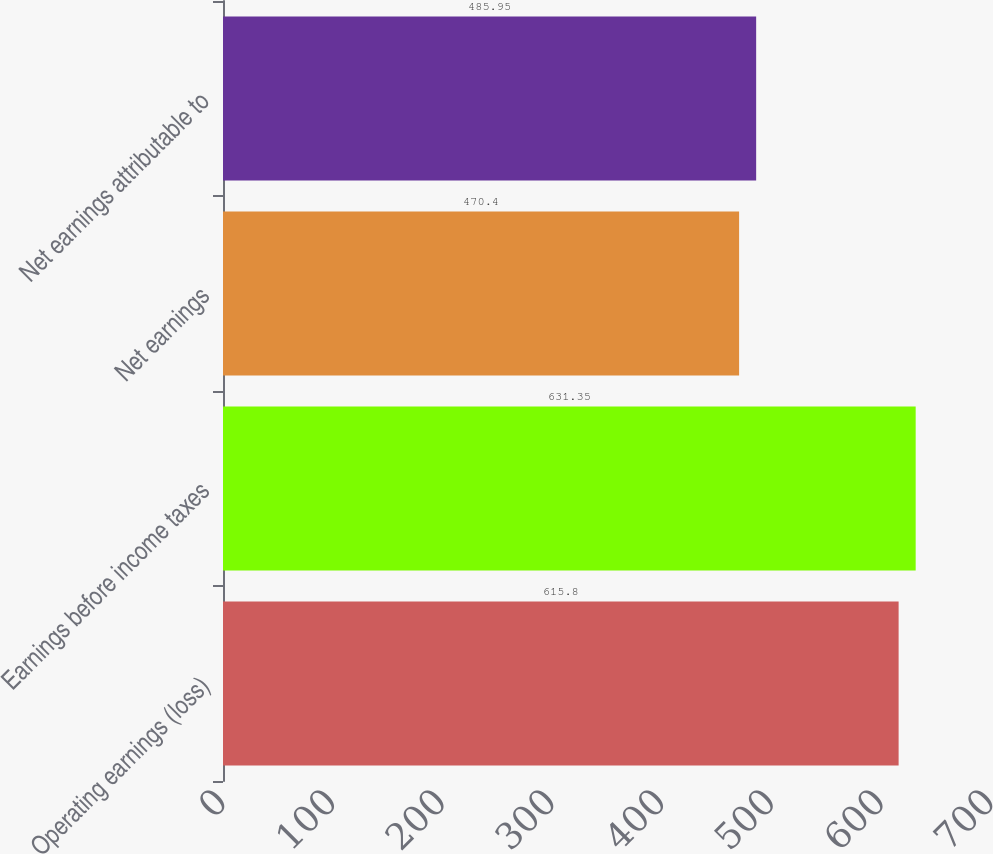Convert chart to OTSL. <chart><loc_0><loc_0><loc_500><loc_500><bar_chart><fcel>Operating earnings (loss)<fcel>Earnings before income taxes<fcel>Net earnings<fcel>Net earnings attributable to<nl><fcel>615.8<fcel>631.35<fcel>470.4<fcel>485.95<nl></chart> 